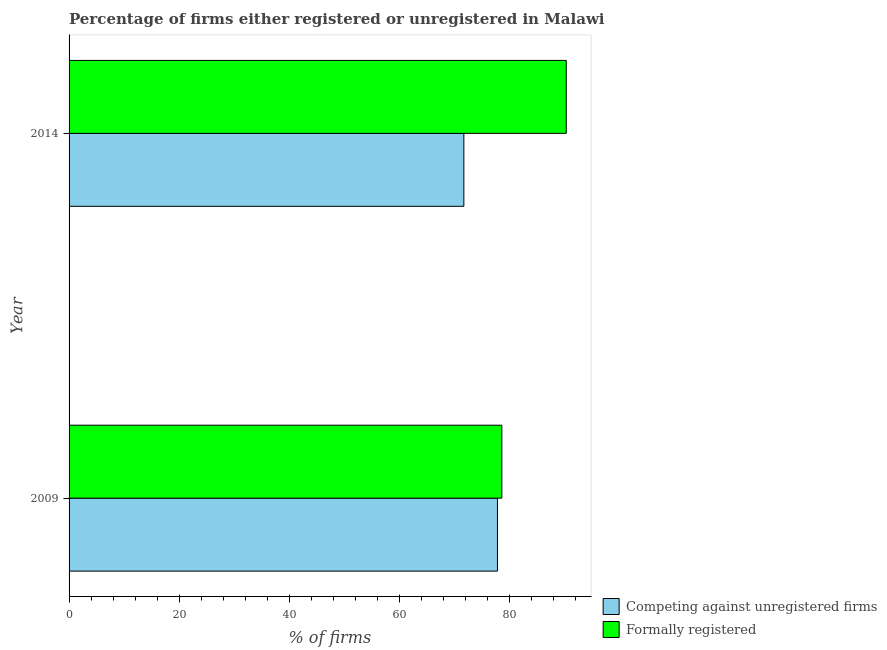In how many cases, is the number of bars for a given year not equal to the number of legend labels?
Ensure brevity in your answer.  0. What is the percentage of registered firms in 2014?
Offer a terse response. 71.7. Across all years, what is the maximum percentage of registered firms?
Your answer should be very brief. 77.8. Across all years, what is the minimum percentage of registered firms?
Make the answer very short. 71.7. In which year was the percentage of formally registered firms minimum?
Your answer should be compact. 2009. What is the total percentage of formally registered firms in the graph?
Your response must be concise. 168.9. What is the difference between the percentage of registered firms in 2009 and the percentage of formally registered firms in 2014?
Your response must be concise. -12.5. What is the average percentage of registered firms per year?
Provide a short and direct response. 74.75. What is the ratio of the percentage of registered firms in 2009 to that in 2014?
Your answer should be very brief. 1.08. Is the percentage of registered firms in 2009 less than that in 2014?
Provide a short and direct response. No. In how many years, is the percentage of registered firms greater than the average percentage of registered firms taken over all years?
Ensure brevity in your answer.  1. What does the 1st bar from the top in 2009 represents?
Provide a succinct answer. Formally registered. What does the 2nd bar from the bottom in 2009 represents?
Provide a short and direct response. Formally registered. How many bars are there?
Offer a terse response. 4. Are all the bars in the graph horizontal?
Provide a short and direct response. Yes. What is the difference between two consecutive major ticks on the X-axis?
Offer a very short reply. 20. Are the values on the major ticks of X-axis written in scientific E-notation?
Provide a succinct answer. No. Does the graph contain any zero values?
Provide a succinct answer. No. How many legend labels are there?
Ensure brevity in your answer.  2. What is the title of the graph?
Provide a short and direct response. Percentage of firms either registered or unregistered in Malawi. Does "From World Bank" appear as one of the legend labels in the graph?
Your answer should be compact. No. What is the label or title of the X-axis?
Provide a short and direct response. % of firms. What is the label or title of the Y-axis?
Offer a terse response. Year. What is the % of firms of Competing against unregistered firms in 2009?
Offer a terse response. 77.8. What is the % of firms of Formally registered in 2009?
Your response must be concise. 78.6. What is the % of firms of Competing against unregistered firms in 2014?
Your answer should be compact. 71.7. What is the % of firms in Formally registered in 2014?
Provide a succinct answer. 90.3. Across all years, what is the maximum % of firms of Competing against unregistered firms?
Give a very brief answer. 77.8. Across all years, what is the maximum % of firms in Formally registered?
Offer a very short reply. 90.3. Across all years, what is the minimum % of firms of Competing against unregistered firms?
Offer a terse response. 71.7. Across all years, what is the minimum % of firms in Formally registered?
Keep it short and to the point. 78.6. What is the total % of firms of Competing against unregistered firms in the graph?
Your answer should be very brief. 149.5. What is the total % of firms in Formally registered in the graph?
Your answer should be compact. 168.9. What is the difference between the % of firms of Formally registered in 2009 and that in 2014?
Offer a very short reply. -11.7. What is the average % of firms of Competing against unregistered firms per year?
Offer a very short reply. 74.75. What is the average % of firms in Formally registered per year?
Offer a very short reply. 84.45. In the year 2014, what is the difference between the % of firms of Competing against unregistered firms and % of firms of Formally registered?
Offer a very short reply. -18.6. What is the ratio of the % of firms in Competing against unregistered firms in 2009 to that in 2014?
Keep it short and to the point. 1.09. What is the ratio of the % of firms in Formally registered in 2009 to that in 2014?
Give a very brief answer. 0.87. What is the difference between the highest and the second highest % of firms of Competing against unregistered firms?
Offer a very short reply. 6.1. What is the difference between the highest and the lowest % of firms in Formally registered?
Offer a terse response. 11.7. 